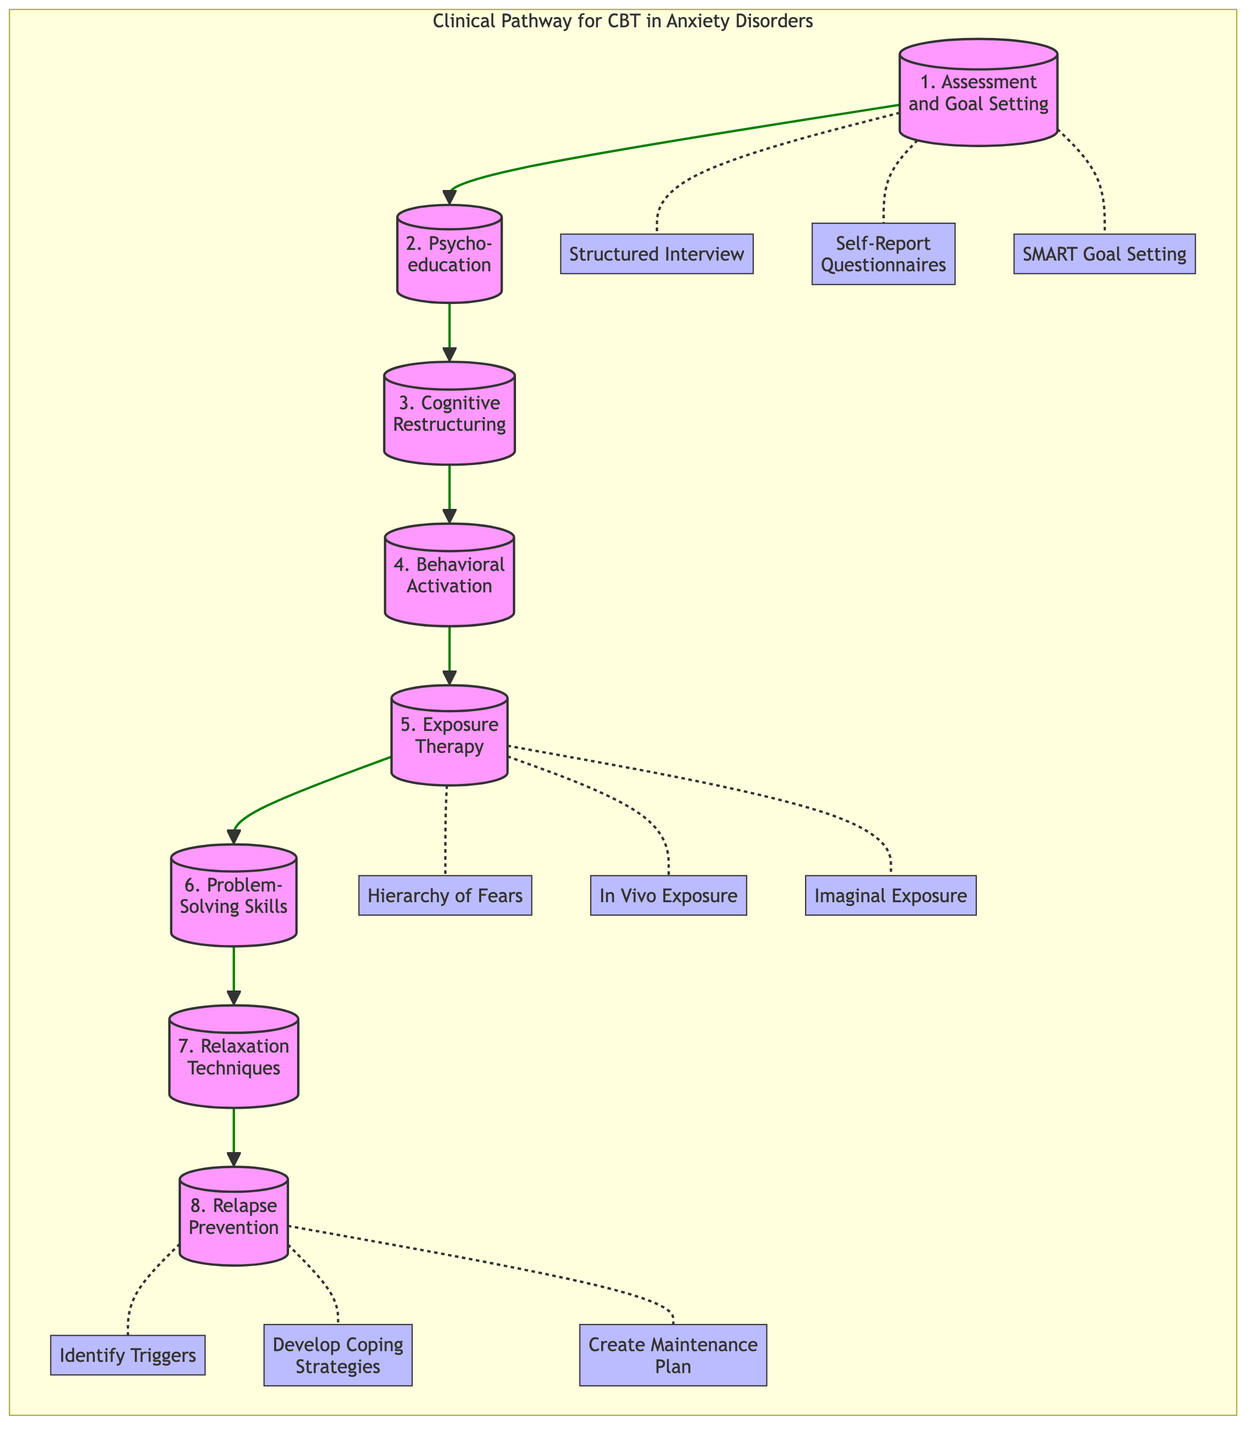What is the first session in the Clinical Pathway for CBT? The first session listed in the diagram is "Assessment and Goal Setting". It is the top-most session in the flow of the pathway.
Answer: Assessment and Goal Setting How many sessions are included in the Clinical Pathway for CBT? By counting the session nodes in the diagram, there are eight sessions listed in total.
Answer: 8 What techniques are associated with the fifth session? The fifth session, "Exposure Therapy", is connected to three techniques: "Hierarchy of Fears", "In Vivo Exposure", and "Imaginal Exposure".
Answer: Hierarchy of Fears, In Vivo Exposure, Imaginal Exposure Which session follows "Cognitive Restructuring"? "Behavioral Activation" is the session that comes after "Cognitive Restructuring" in the flow of the diagram.
Answer: Behavioral Activation What is the last technique listed in the Clinical Pathway? The last technique associated with the final session, "Relapse Prevention", is "Creating a Maintenance Plan". It appears at the end of the associated techniques.
Answer: Creating a Maintenance Plan Explain the flow from "Assessment and Goal Setting" to "Exposure Therapy". Starting from "Assessment and Goal Setting", the flow progresses sequentially through "Psychoeducation" to "Cognitive Restructuring", then to "Behavioral Activation", and finally reaches "Exposure Therapy". This shows a linear progression through five sessions before reaching exposure techniques.
Answer: Sequential flow through five sessions What types of techniques are included in the seventh session? The seventh session, "Relaxation Techniques", incorporates three specific techniques: "Progressive Muscle Relaxation", "Deep Breathing Exercises", and "Mindfulness Meditation".
Answer: Progressive Muscle Relaxation, Deep Breathing Exercises, Mindfulness Meditation Which session focuses on developing coping strategies? The session dedicated to developing coping strategies is "Relapse Prevention", as indicated by the techniques associated with it.
Answer: Relapse Prevention 